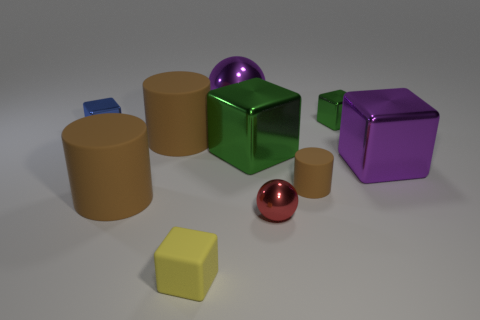Subtract all purple blocks. How many blocks are left? 4 Subtract all big green blocks. How many blocks are left? 4 Subtract all red cubes. Subtract all brown spheres. How many cubes are left? 5 Subtract all balls. How many objects are left? 8 Subtract 1 purple spheres. How many objects are left? 9 Subtract all big purple objects. Subtract all tiny blue objects. How many objects are left? 7 Add 5 big brown matte objects. How many big brown matte objects are left? 7 Add 6 large gray balls. How many large gray balls exist? 6 